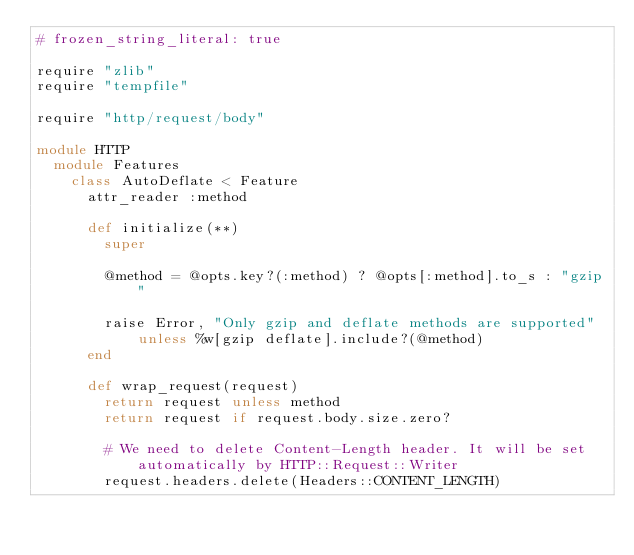Convert code to text. <code><loc_0><loc_0><loc_500><loc_500><_Ruby_># frozen_string_literal: true

require "zlib"
require "tempfile"

require "http/request/body"

module HTTP
  module Features
    class AutoDeflate < Feature
      attr_reader :method

      def initialize(**)
        super

        @method = @opts.key?(:method) ? @opts[:method].to_s : "gzip"

        raise Error, "Only gzip and deflate methods are supported" unless %w[gzip deflate].include?(@method)
      end

      def wrap_request(request)
        return request unless method
        return request if request.body.size.zero?

        # We need to delete Content-Length header. It will be set automatically by HTTP::Request::Writer
        request.headers.delete(Headers::CONTENT_LENGTH)</code> 